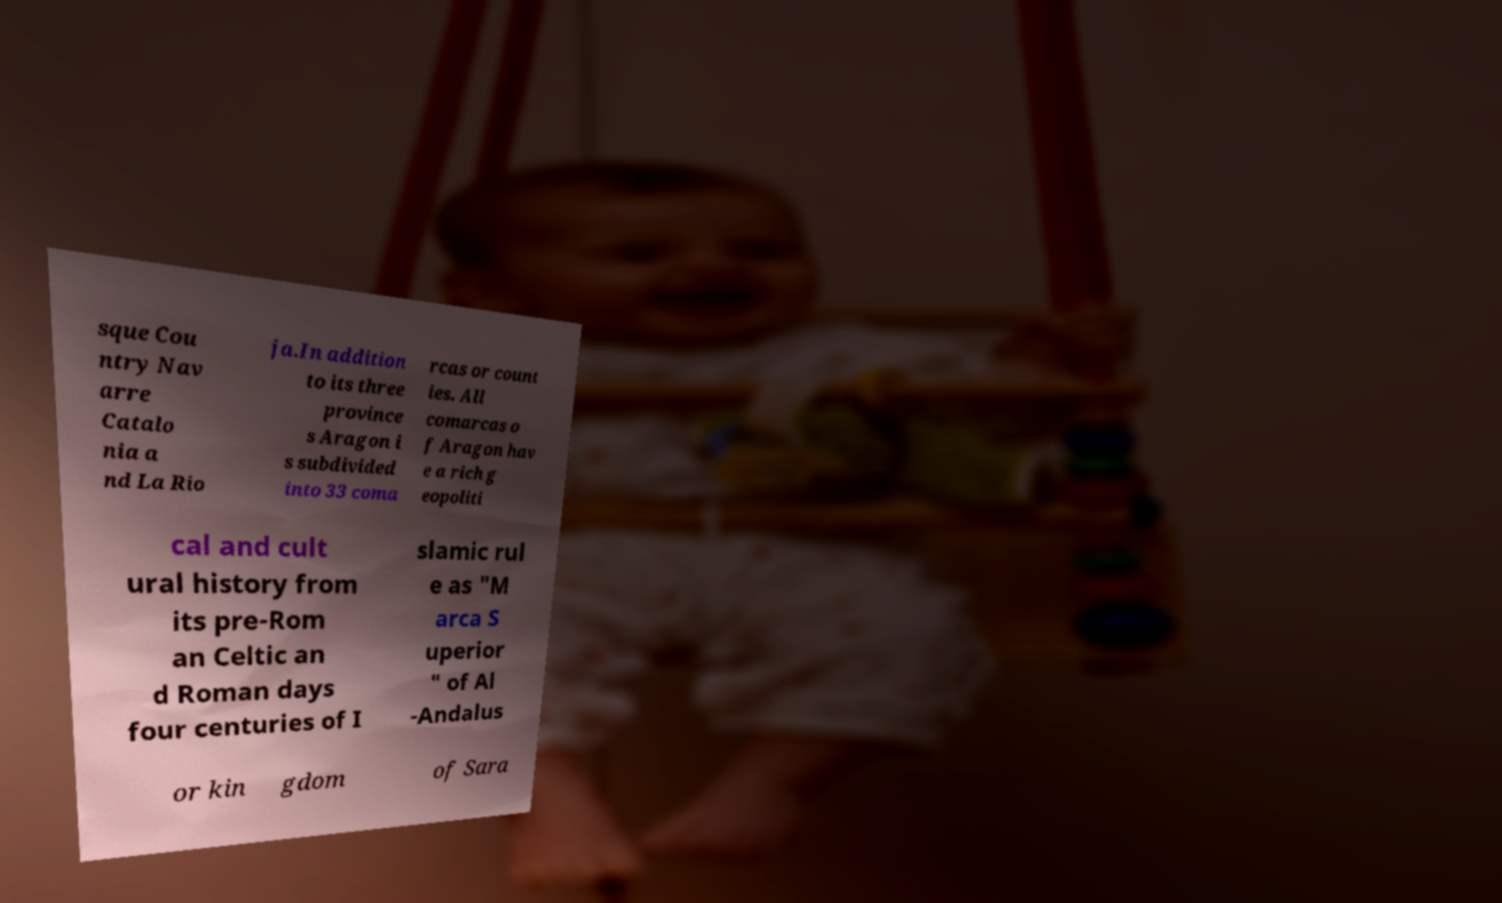There's text embedded in this image that I need extracted. Can you transcribe it verbatim? sque Cou ntry Nav arre Catalo nia a nd La Rio ja.In addition to its three province s Aragon i s subdivided into 33 coma rcas or count ies. All comarcas o f Aragon hav e a rich g eopoliti cal and cult ural history from its pre-Rom an Celtic an d Roman days four centuries of I slamic rul e as "M arca S uperior " of Al -Andalus or kin gdom of Sara 